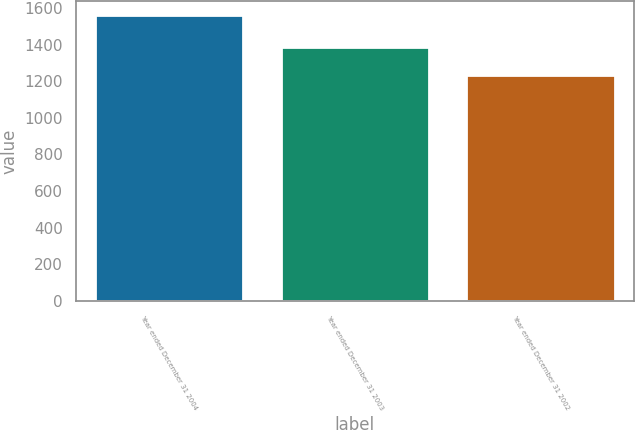Convert chart to OTSL. <chart><loc_0><loc_0><loc_500><loc_500><bar_chart><fcel>Year ended December 31 2004<fcel>Year ended December 31 2003<fcel>Year ended December 31 2002<nl><fcel>1561<fcel>1388<fcel>1236<nl></chart> 